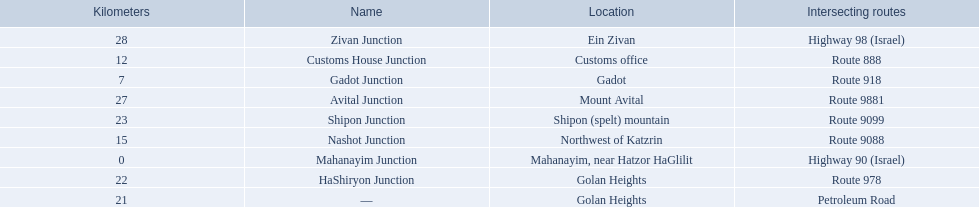Which junctions cross a route? Gadot Junction, Customs House Junction, Nashot Junction, HaShiryon Junction, Shipon Junction, Avital Junction. Which of these shares [art of its name with its locations name? Gadot Junction, Customs House Junction, Shipon Junction, Avital Junction. Which of them is not located in a locations named after a mountain? Gadot Junction, Customs House Junction. Which of these has the highest route number? Gadot Junction. 